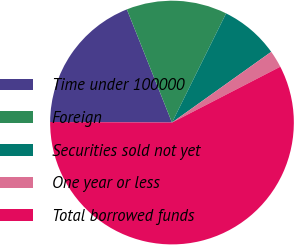<chart> <loc_0><loc_0><loc_500><loc_500><pie_chart><fcel>Time under 100000<fcel>Foreign<fcel>Securities sold not yet<fcel>One year or less<fcel>Total borrowed funds<nl><fcel>18.89%<fcel>13.36%<fcel>7.82%<fcel>2.28%<fcel>57.65%<nl></chart> 